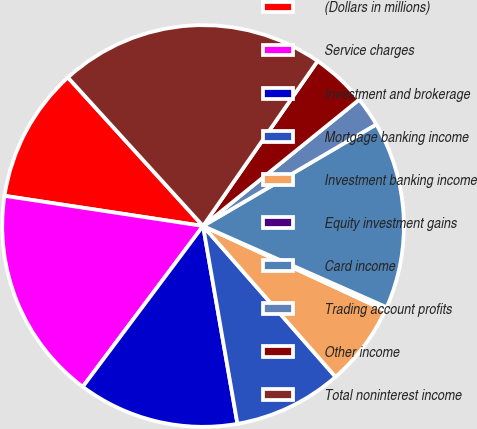<chart> <loc_0><loc_0><loc_500><loc_500><pie_chart><fcel>(Dollars in millions)<fcel>Service charges<fcel>Investment and brokerage<fcel>Mortgage banking income<fcel>Investment banking income<fcel>Equity investment gains<fcel>Card income<fcel>Trading account profits<fcel>Other income<fcel>Total noninterest income<nl><fcel>10.85%<fcel>17.18%<fcel>12.96%<fcel>8.73%<fcel>6.62%<fcel>0.28%<fcel>15.07%<fcel>2.39%<fcel>4.51%<fcel>21.41%<nl></chart> 